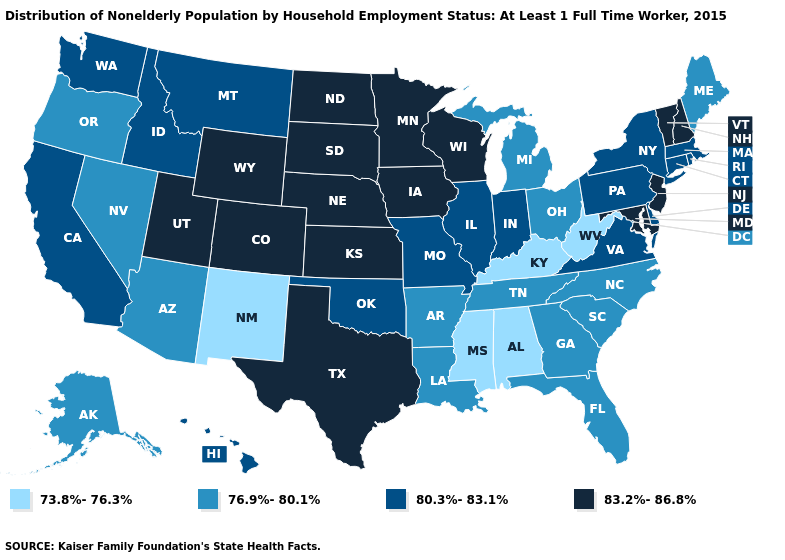What is the value of Utah?
Answer briefly. 83.2%-86.8%. Name the states that have a value in the range 80.3%-83.1%?
Short answer required. California, Connecticut, Delaware, Hawaii, Idaho, Illinois, Indiana, Massachusetts, Missouri, Montana, New York, Oklahoma, Pennsylvania, Rhode Island, Virginia, Washington. Name the states that have a value in the range 76.9%-80.1%?
Give a very brief answer. Alaska, Arizona, Arkansas, Florida, Georgia, Louisiana, Maine, Michigan, Nevada, North Carolina, Ohio, Oregon, South Carolina, Tennessee. Does the first symbol in the legend represent the smallest category?
Short answer required. Yes. Among the states that border Nebraska , does Kansas have the highest value?
Give a very brief answer. Yes. Does Ohio have the lowest value in the MidWest?
Answer briefly. Yes. Does North Carolina have a higher value than North Dakota?
Answer briefly. No. Does the first symbol in the legend represent the smallest category?
Keep it brief. Yes. Name the states that have a value in the range 83.2%-86.8%?
Short answer required. Colorado, Iowa, Kansas, Maryland, Minnesota, Nebraska, New Hampshire, New Jersey, North Dakota, South Dakota, Texas, Utah, Vermont, Wisconsin, Wyoming. Which states hav the highest value in the West?
Give a very brief answer. Colorado, Utah, Wyoming. Among the states that border Michigan , does Wisconsin have the highest value?
Be succinct. Yes. Which states have the highest value in the USA?
Short answer required. Colorado, Iowa, Kansas, Maryland, Minnesota, Nebraska, New Hampshire, New Jersey, North Dakota, South Dakota, Texas, Utah, Vermont, Wisconsin, Wyoming. What is the value of Rhode Island?
Be succinct. 80.3%-83.1%. Name the states that have a value in the range 73.8%-76.3%?
Be succinct. Alabama, Kentucky, Mississippi, New Mexico, West Virginia. Is the legend a continuous bar?
Write a very short answer. No. 